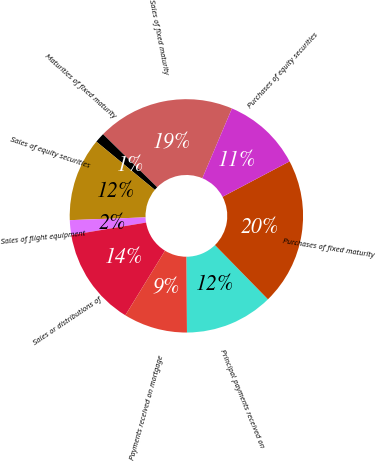Convert chart to OTSL. <chart><loc_0><loc_0><loc_500><loc_500><pie_chart><fcel>Sales of fixed maturity<fcel>Maturities of fixed maturity<fcel>Sales of equity securities<fcel>Sales of flight equipment<fcel>Sales or distributions of<fcel>Payments received on mortgage<fcel>Principal payments received on<fcel>Purchases of fixed maturity<fcel>Purchases of equity securities<nl><fcel>19.05%<fcel>1.36%<fcel>11.56%<fcel>2.04%<fcel>13.61%<fcel>8.84%<fcel>12.24%<fcel>20.41%<fcel>10.88%<nl></chart> 